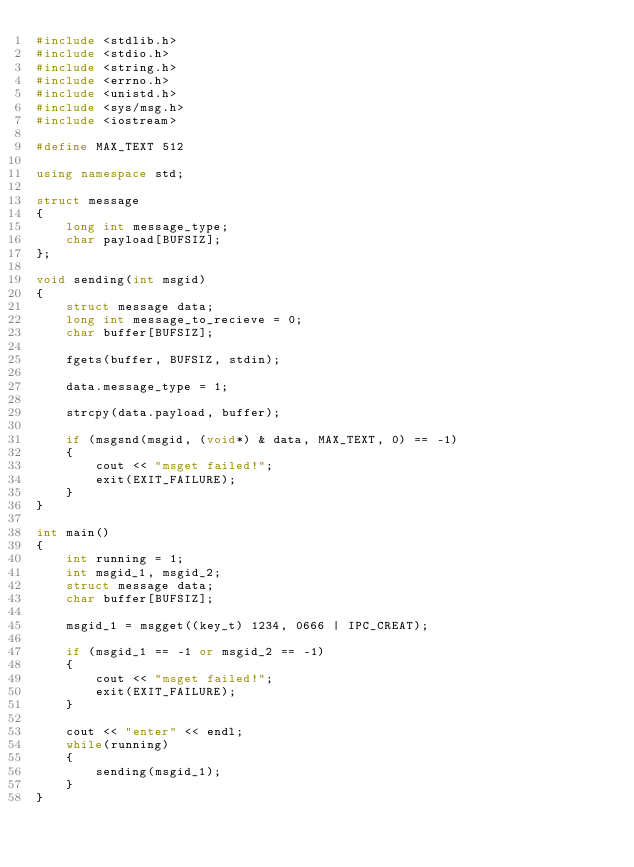Convert code to text. <code><loc_0><loc_0><loc_500><loc_500><_C++_>#include <stdlib.h>
#include <stdio.h>
#include <string.h>
#include <errno.h>
#include <unistd.h>
#include <sys/msg.h>
#include <iostream>

#define MAX_TEXT 512

using namespace std;

struct message
{
    long int message_type;
    char payload[BUFSIZ];
};

void sending(int msgid)
{
    struct message data;
    long int message_to_recieve = 0;
    char buffer[BUFSIZ];

    fgets(buffer, BUFSIZ, stdin);

    data.message_type = 1;

    strcpy(data.payload, buffer);

    if (msgsnd(msgid, (void*) & data, MAX_TEXT, 0) == -1)
    {
        cout << "msget failed!";
        exit(EXIT_FAILURE);
    }
}

int main()
{
    int running = 1;
    int msgid_1, msgid_2;
    struct message data;
    char buffer[BUFSIZ];

    msgid_1 = msgget((key_t) 1234, 0666 | IPC_CREAT);

    if (msgid_1 == -1 or msgid_2 == -1)
    {
        cout << "msget failed!";
        exit(EXIT_FAILURE);
    }

    cout << "enter" << endl;
    while(running)
    {
        sending(msgid_1);
    }
}
</code> 